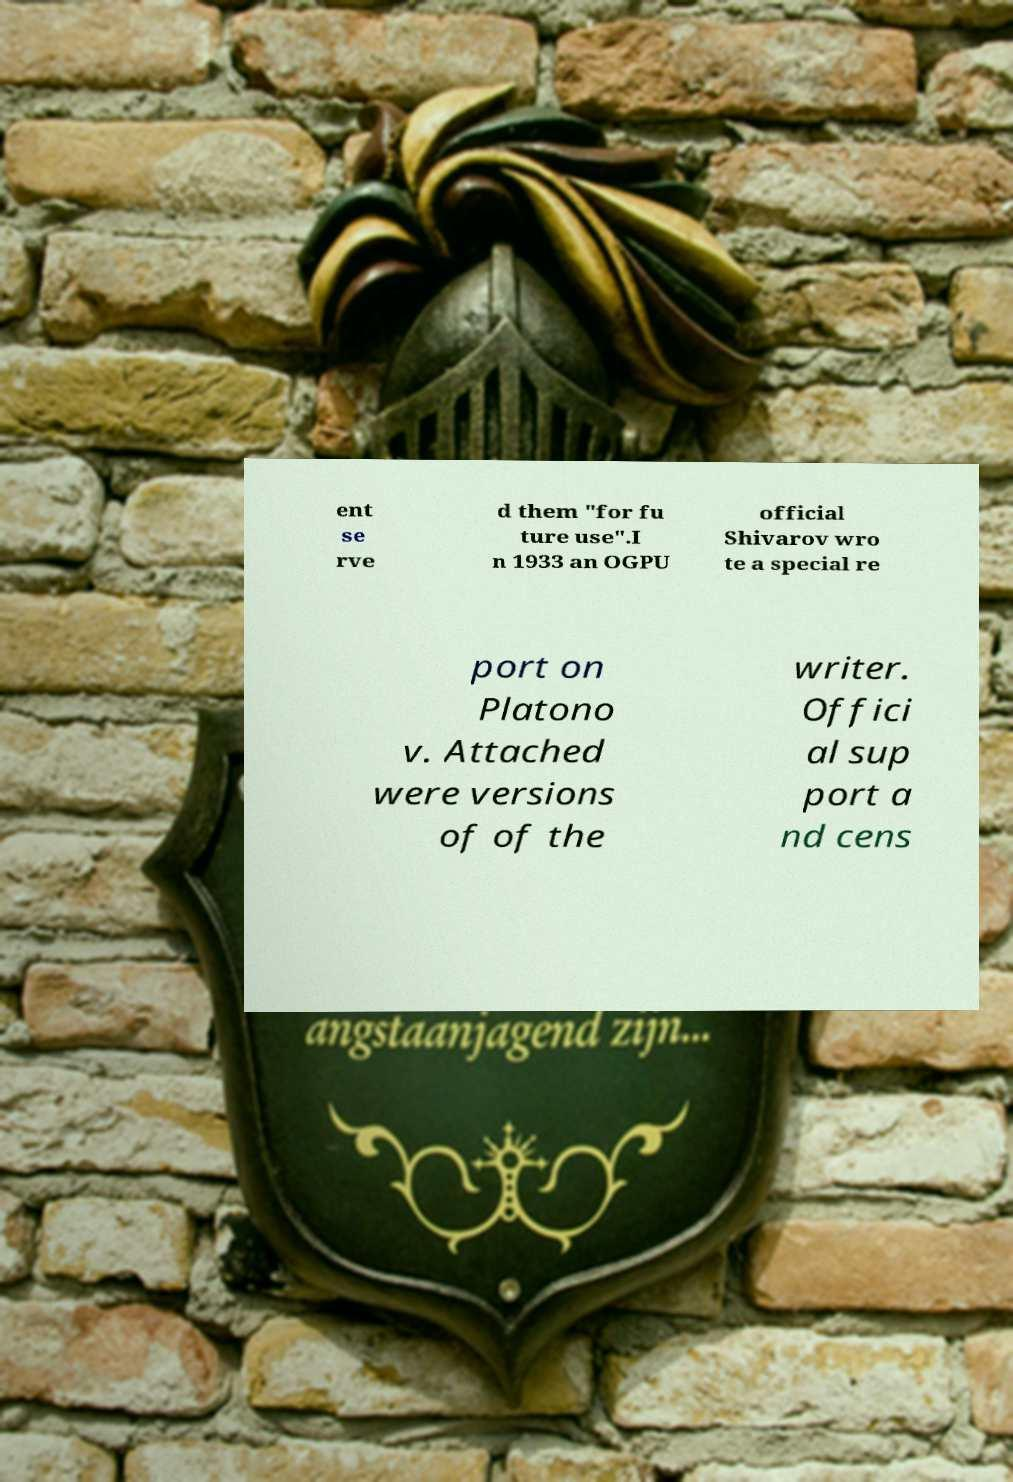What messages or text are displayed in this image? I need them in a readable, typed format. ent se rve d them "for fu ture use".I n 1933 an OGPU official Shivarov wro te a special re port on Platono v. Attached were versions of of the writer. Offici al sup port a nd cens 